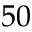<formula> <loc_0><loc_0><loc_500><loc_500>5 0</formula> 